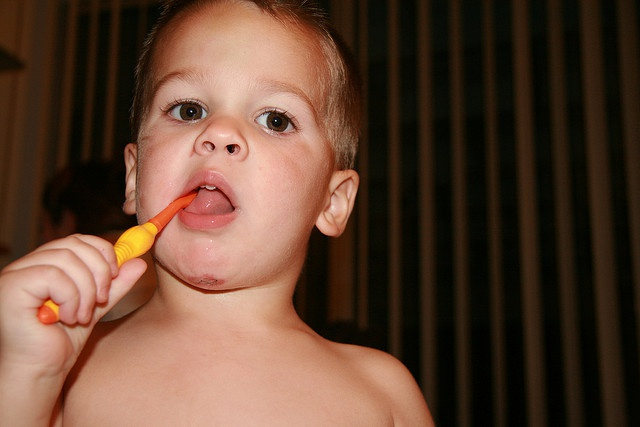Describe the objects in this image and their specific colors. I can see people in maroon, tan, salmon, and black tones and toothbrush in maroon, orange, red, gold, and brown tones in this image. 